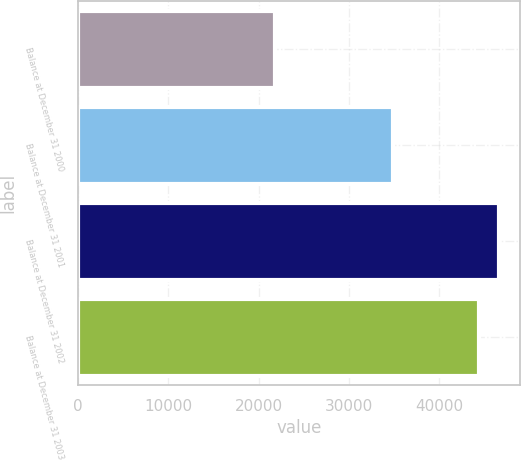<chart> <loc_0><loc_0><loc_500><loc_500><bar_chart><fcel>Balance at December 31 2000<fcel>Balance at December 31 2001<fcel>Balance at December 31 2002<fcel>Balance at December 31 2003<nl><fcel>21858<fcel>34873<fcel>46634.3<fcel>44374<nl></chart> 